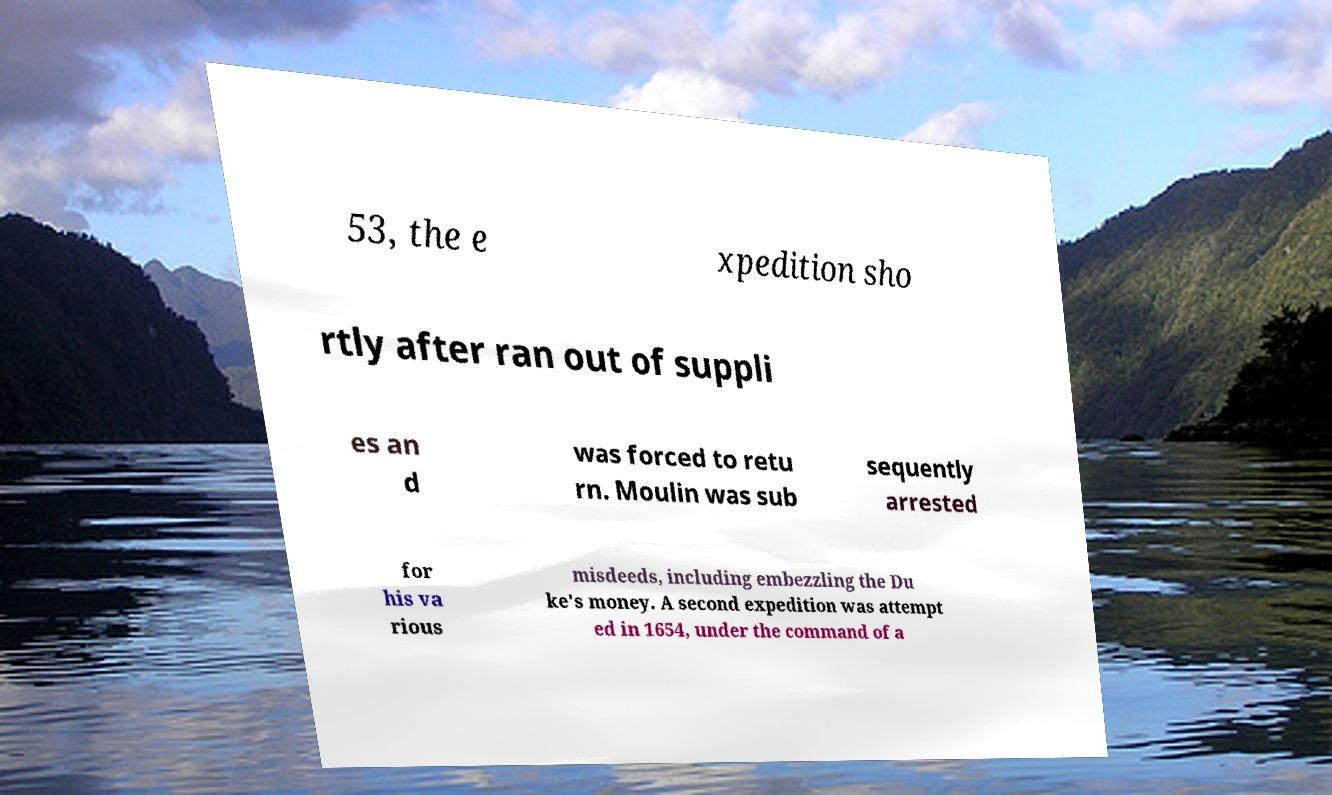Can you accurately transcribe the text from the provided image for me? 53, the e xpedition sho rtly after ran out of suppli es an d was forced to retu rn. Moulin was sub sequently arrested for his va rious misdeeds, including embezzling the Du ke's money. A second expedition was attempt ed in 1654, under the command of a 